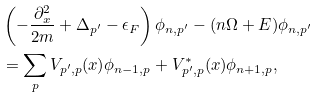<formula> <loc_0><loc_0><loc_500><loc_500>& \left ( - \frac { \partial _ { x } ^ { 2 } } { 2 m } + \Delta _ { p ^ { \prime } } - \epsilon _ { F } \right ) \phi _ { n , p ^ { \prime } } - ( n \Omega + E ) \phi _ { n , p ^ { \prime } } \\ & = \sum _ { p } V _ { p ^ { \prime } , p } ( x ) \phi _ { n - 1 , p } + V ^ { * } _ { p ^ { \prime } , p } ( x ) \phi _ { n + 1 , p } ,</formula> 